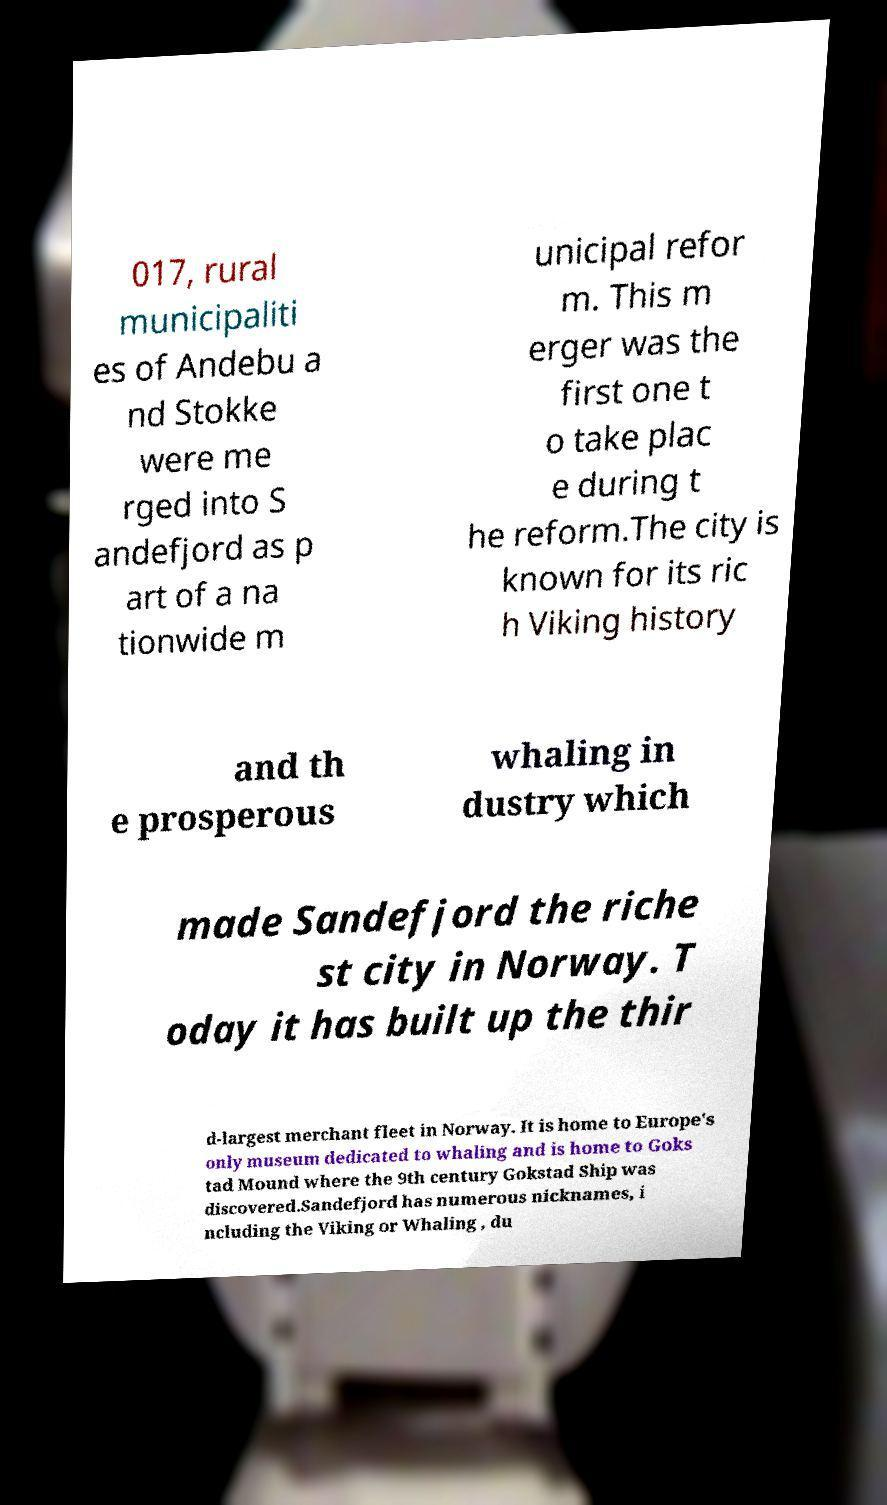Please identify and transcribe the text found in this image. 017, rural municipaliti es of Andebu a nd Stokke were me rged into S andefjord as p art of a na tionwide m unicipal refor m. This m erger was the first one t o take plac e during t he reform.The city is known for its ric h Viking history and th e prosperous whaling in dustry which made Sandefjord the riche st city in Norway. T oday it has built up the thir d-largest merchant fleet in Norway. It is home to Europe's only museum dedicated to whaling and is home to Goks tad Mound where the 9th century Gokstad Ship was discovered.Sandefjord has numerous nicknames, i ncluding the Viking or Whaling , du 